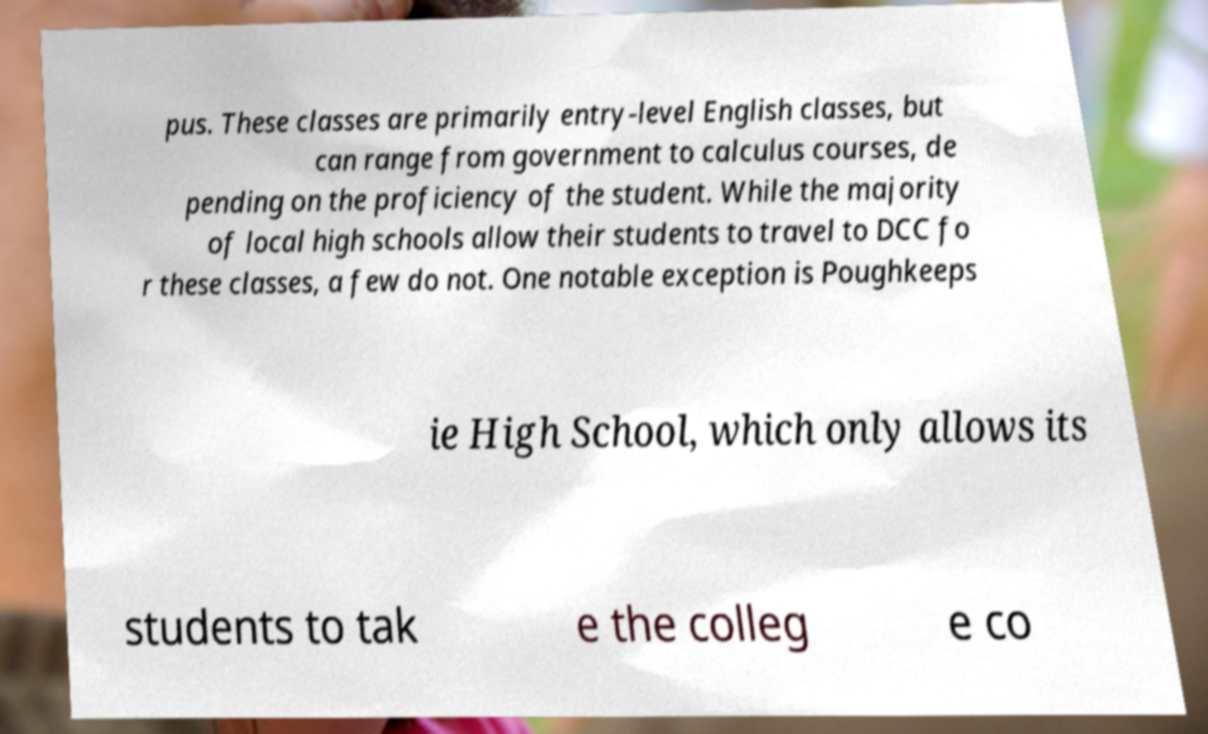Please identify and transcribe the text found in this image. pus. These classes are primarily entry-level English classes, but can range from government to calculus courses, de pending on the proficiency of the student. While the majority of local high schools allow their students to travel to DCC fo r these classes, a few do not. One notable exception is Poughkeeps ie High School, which only allows its students to tak e the colleg e co 